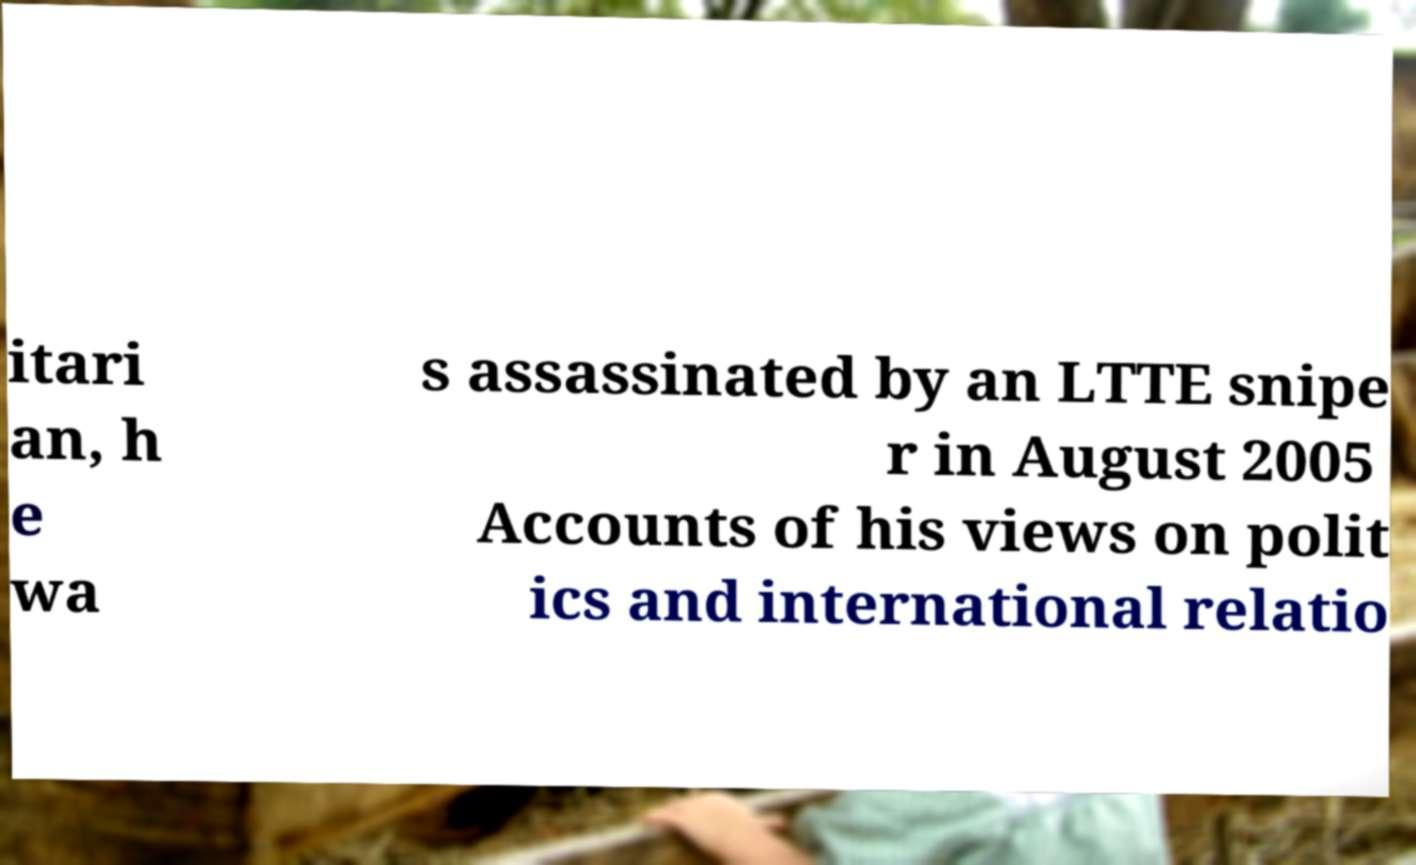Could you extract and type out the text from this image? itari an, h e wa s assassinated by an LTTE snipe r in August 2005 Accounts of his views on polit ics and international relatio 